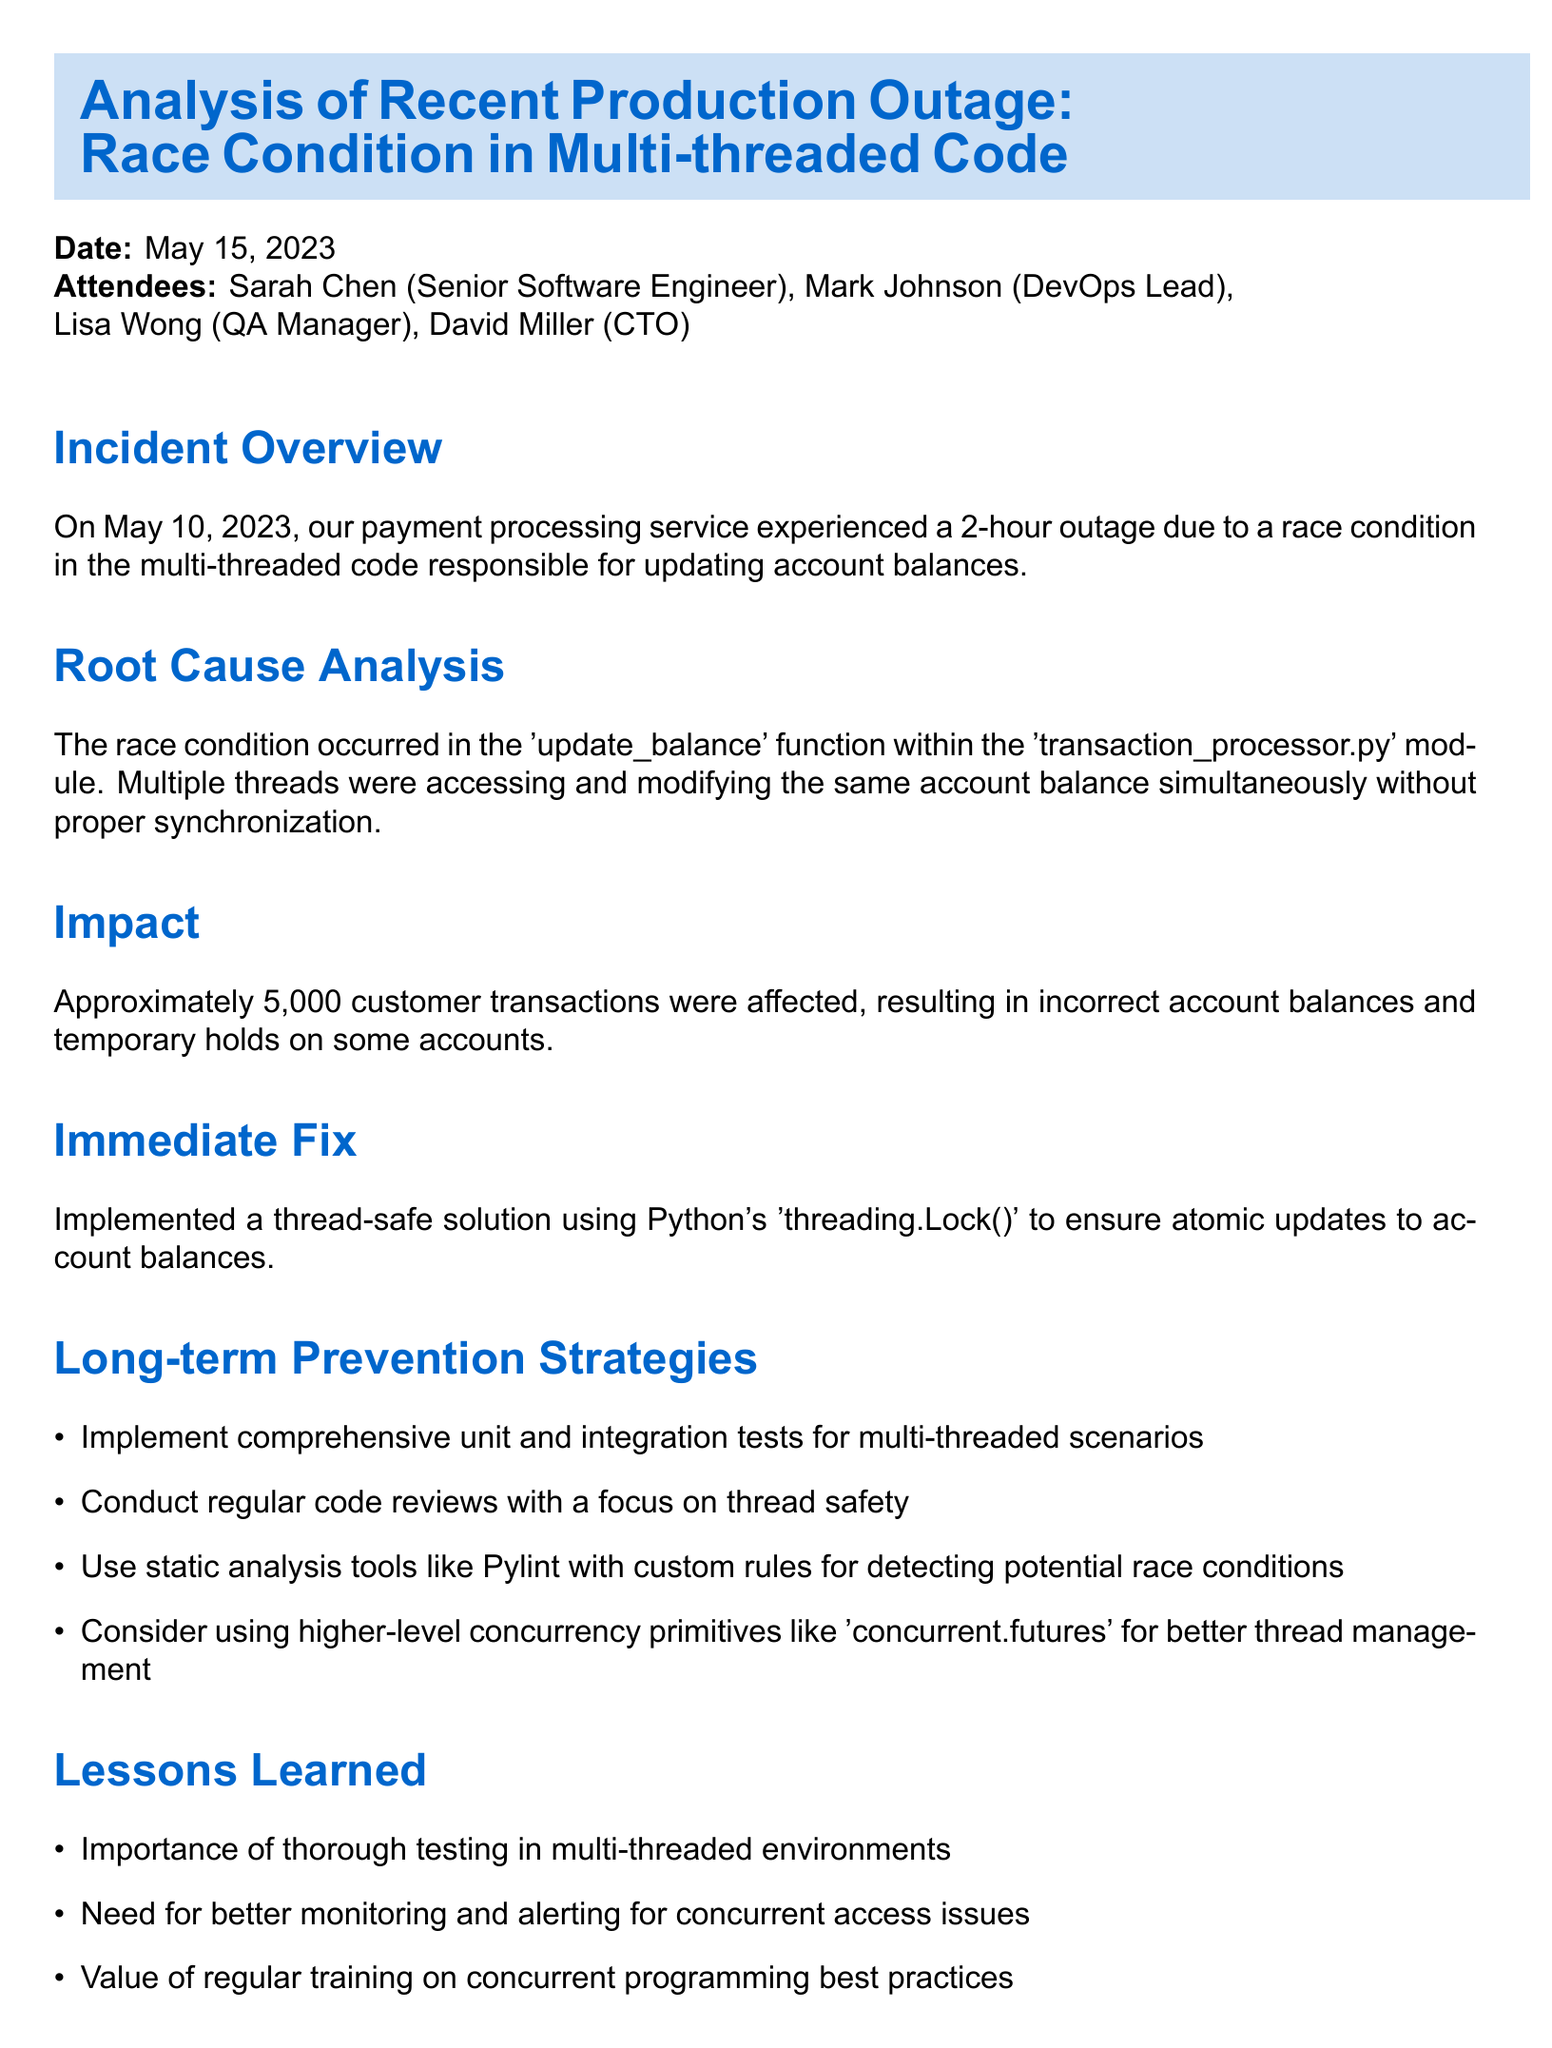What was the date of the outage? The date of the outage is mentioned in the 'Incident Overview' section of the document.
Answer: May 10, 2023 Who is assigned to develop a suite of stress tests? The 'Action Items' section specifies the assignee for each task.
Answer: Sarah Chen What immediate fix was implemented? The 'Immediate Fix' section outlines the solution that was put in place.
Answer: threading.Lock() How many transactions were affected by the outage? The 'Impact' section provides the number of affected transactions.
Answer: 5,000 What long-term prevention strategy involves code reviews? The 'Long-term Prevention Strategies' section lists prevention strategies, one of which focuses on this.
Answer: Conduct regular code reviews with a focus on thread safety What is one lesson learned from the outage? The 'Lessons Learned' section includes various insights gained from the incident.
Answer: Importance of thorough testing in multi-threaded environments When is the team workshop on Python concurrency patterns scheduled? This information is found in the 'Action Items' section under the due date for that specific task.
Answer: 2023-06-15 Which module contained the race condition? The 'Root Cause Analysis' section identifies the module where the issue occurred.
Answer: transaction_processor.py 